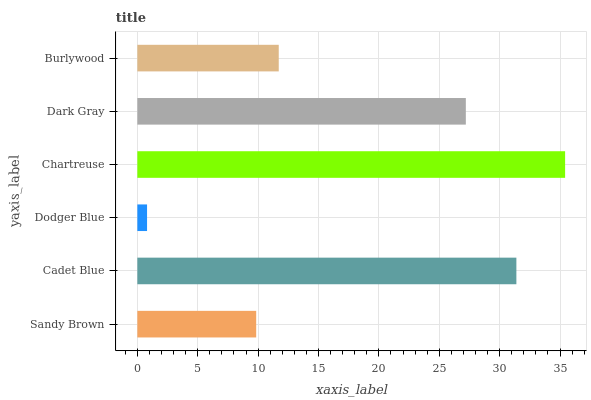Is Dodger Blue the minimum?
Answer yes or no. Yes. Is Chartreuse the maximum?
Answer yes or no. Yes. Is Cadet Blue the minimum?
Answer yes or no. No. Is Cadet Blue the maximum?
Answer yes or no. No. Is Cadet Blue greater than Sandy Brown?
Answer yes or no. Yes. Is Sandy Brown less than Cadet Blue?
Answer yes or no. Yes. Is Sandy Brown greater than Cadet Blue?
Answer yes or no. No. Is Cadet Blue less than Sandy Brown?
Answer yes or no. No. Is Dark Gray the high median?
Answer yes or no. Yes. Is Burlywood the low median?
Answer yes or no. Yes. Is Chartreuse the high median?
Answer yes or no. No. Is Sandy Brown the low median?
Answer yes or no. No. 